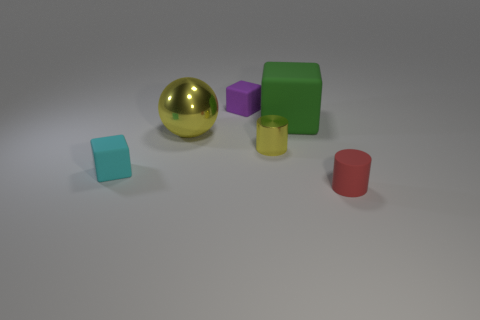Is the number of small red rubber cylinders less than the number of tiny gray blocks?
Your answer should be compact. No. What is the color of the matte block that is both left of the yellow shiny cylinder and behind the yellow sphere?
Make the answer very short. Purple. There is a small yellow object that is the same shape as the tiny red matte object; what is its material?
Make the answer very short. Metal. Is the number of small purple cubes greater than the number of blocks?
Provide a succinct answer. No. What is the size of the thing that is on the left side of the small metallic object and behind the big yellow ball?
Give a very brief answer. Small. The small yellow metallic object is what shape?
Your answer should be compact. Cylinder. How many other matte objects have the same shape as the tiny cyan thing?
Offer a very short reply. 2. Are there fewer big metal things right of the green matte object than small yellow objects in front of the purple rubber object?
Ensure brevity in your answer.  Yes. There is a small object right of the big green rubber thing; what number of purple matte objects are behind it?
Your answer should be very brief. 1. Is there a green matte cube?
Make the answer very short. Yes. 